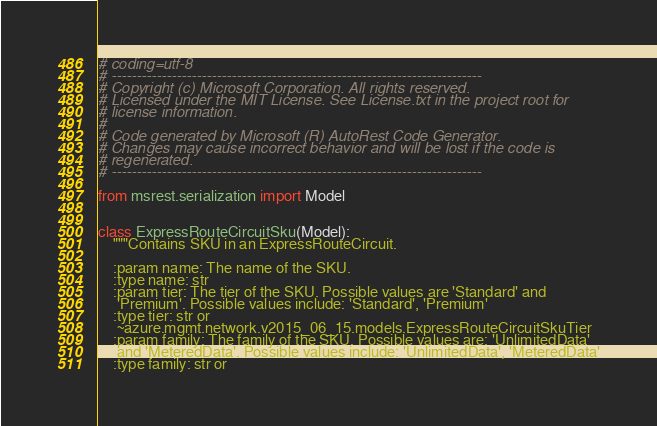<code> <loc_0><loc_0><loc_500><loc_500><_Python_># coding=utf-8
# --------------------------------------------------------------------------
# Copyright (c) Microsoft Corporation. All rights reserved.
# Licensed under the MIT License. See License.txt in the project root for
# license information.
#
# Code generated by Microsoft (R) AutoRest Code Generator.
# Changes may cause incorrect behavior and will be lost if the code is
# regenerated.
# --------------------------------------------------------------------------

from msrest.serialization import Model


class ExpressRouteCircuitSku(Model):
    """Contains SKU in an ExpressRouteCircuit.

    :param name: The name of the SKU.
    :type name: str
    :param tier: The tier of the SKU. Possible values are 'Standard' and
     'Premium'. Possible values include: 'Standard', 'Premium'
    :type tier: str or
     ~azure.mgmt.network.v2015_06_15.models.ExpressRouteCircuitSkuTier
    :param family: The family of the SKU. Possible values are: 'UnlimitedData'
     and 'MeteredData'. Possible values include: 'UnlimitedData', 'MeteredData'
    :type family: str or</code> 